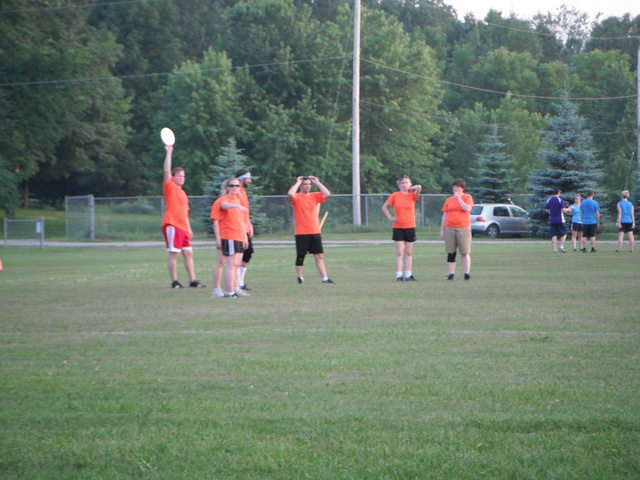Describe the objects in this image and their specific colors. I can see people in black, darkgray, salmon, lightpink, and gray tones, people in black, salmon, darkgray, and gray tones, people in black, darkgray, salmon, gray, and lightpink tones, people in black, lightpink, salmon, and darkgray tones, and people in black, salmon, darkgray, and lightpink tones in this image. 